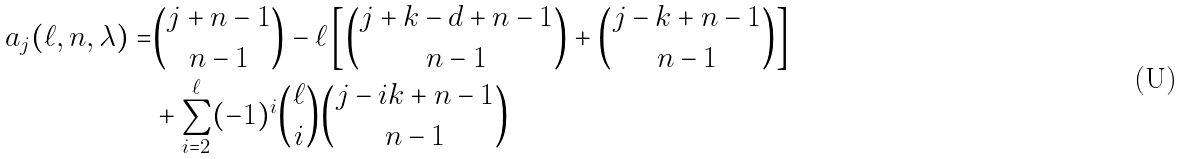<formula> <loc_0><loc_0><loc_500><loc_500>a _ { j } ( \ell , n , \lambda ) = & \binom { j + n - 1 } { n - 1 } - \ell \left [ \binom { j + k - d + n - 1 } { n - 1 } + \binom { j - k + n - 1 } { n - 1 } \right ] \\ & + \sum _ { i = 2 } ^ { \ell } ( - 1 ) ^ { i } \binom { \ell } { i } \binom { j - i k + n - 1 } { n - 1 }</formula> 